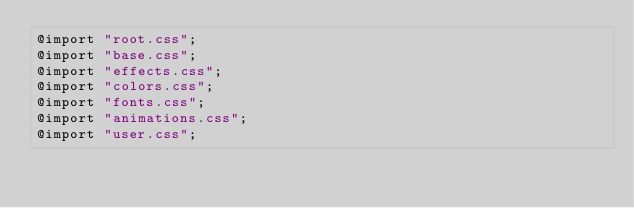<code> <loc_0><loc_0><loc_500><loc_500><_CSS_>@import "root.css";
@import "base.css"; 
@import "effects.css"; 
@import "colors.css"; 
@import "fonts.css"; 
@import "animations.css"; 
@import "user.css"; 
</code> 